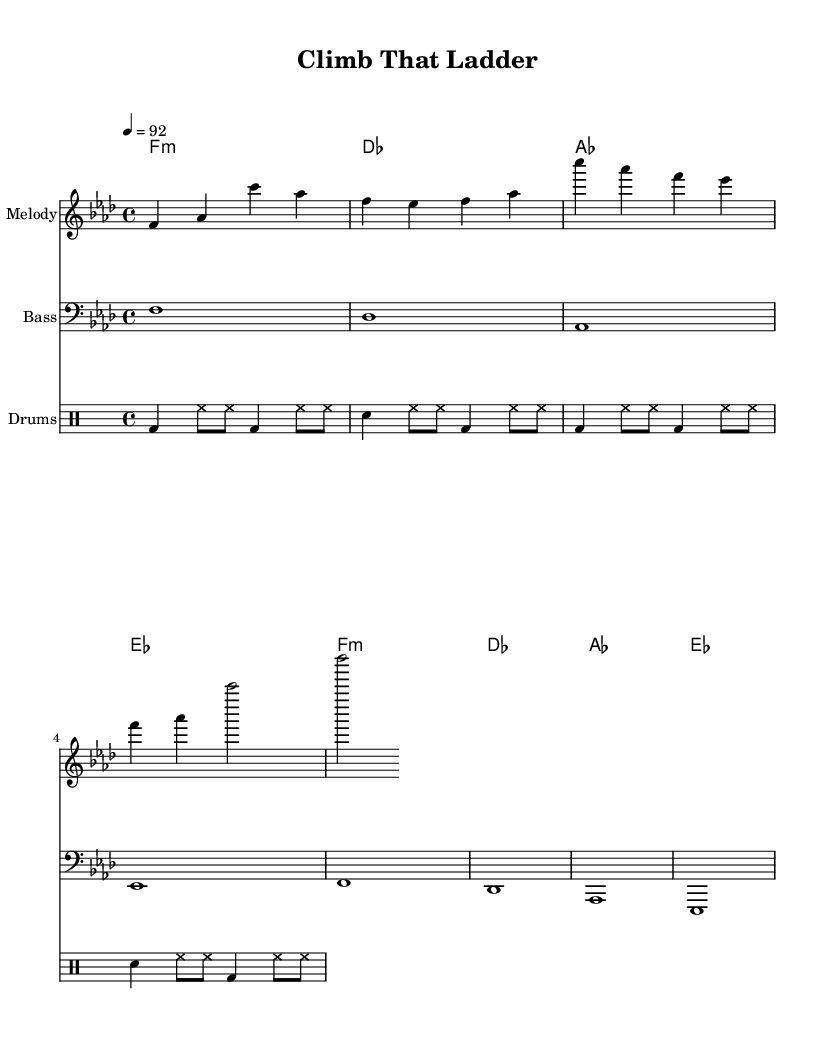What is the key signature of this music? The key signature indicates the key of F minor, as there are four flats present in the score.
Answer: F minor What is the time signature of this piece? The time signature is found at the beginning of the music and is set as 4/4, indicating four beats per measure.
Answer: 4/4 What is the indicated tempo for the song? The tempo marking is at the beginning of the score, indicating a pace of 92 beats per minute.
Answer: 92 How many measures are there in the melody? By counting the individual groups separated by vertical lines (bar lines), there are 8 measures in the melody.
Answer: 8 Which instrument plays the melody? The staff labeled "Melody" indicates that this part is specifically for the lead instrument, which is usually a vocal or a solo instrument.
Answer: Melody What is the function of the bass in this piece? The bass provides the harmonic foundation and rhythmic support, as indicated by the bass staff containing lower notes that follow the chord progression.
Answer: Harmonic foundation What is the main theme of the lyrics in this song? The lyrics emphasize ambition and perseverance, reflecting a motivational message associated with climbing the corporate ladder.
Answer: Motivation 